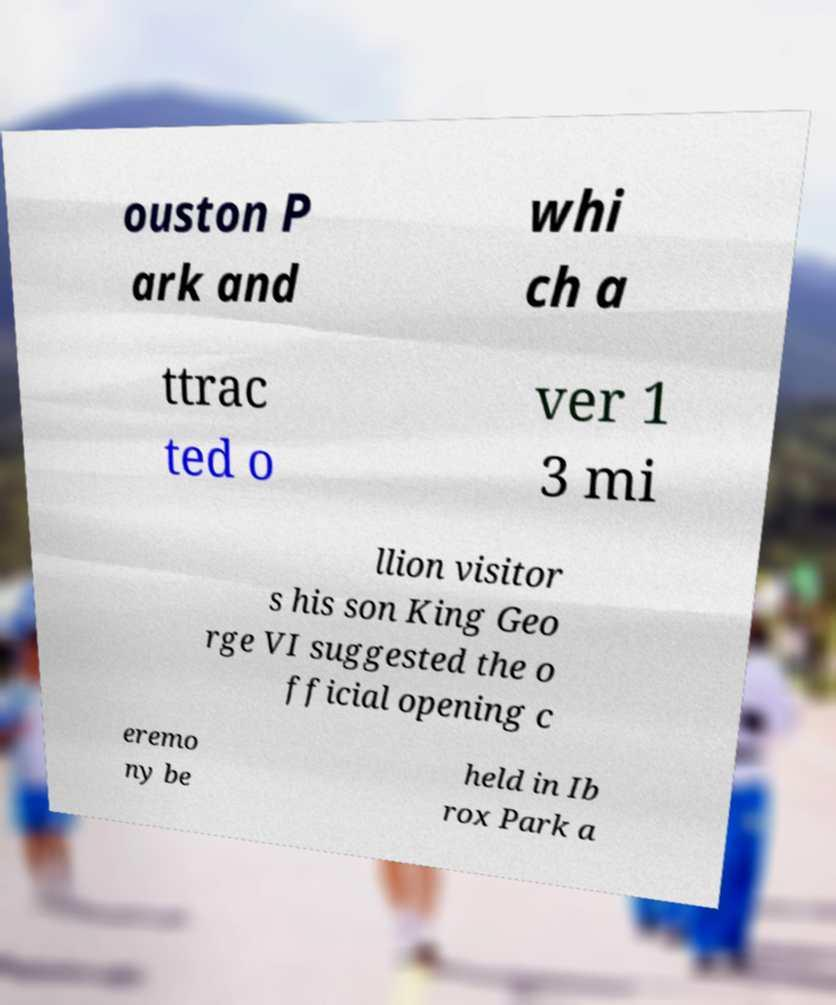Please identify and transcribe the text found in this image. ouston P ark and whi ch a ttrac ted o ver 1 3 mi llion visitor s his son King Geo rge VI suggested the o fficial opening c eremo ny be held in Ib rox Park a 